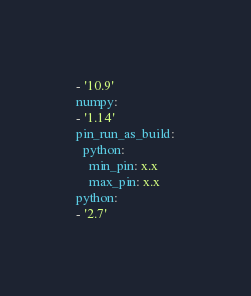Convert code to text. <code><loc_0><loc_0><loc_500><loc_500><_YAML_>- '10.9'
numpy:
- '1.14'
pin_run_as_build:
  python:
    min_pin: x.x
    max_pin: x.x
python:
- '2.7'
</code> 